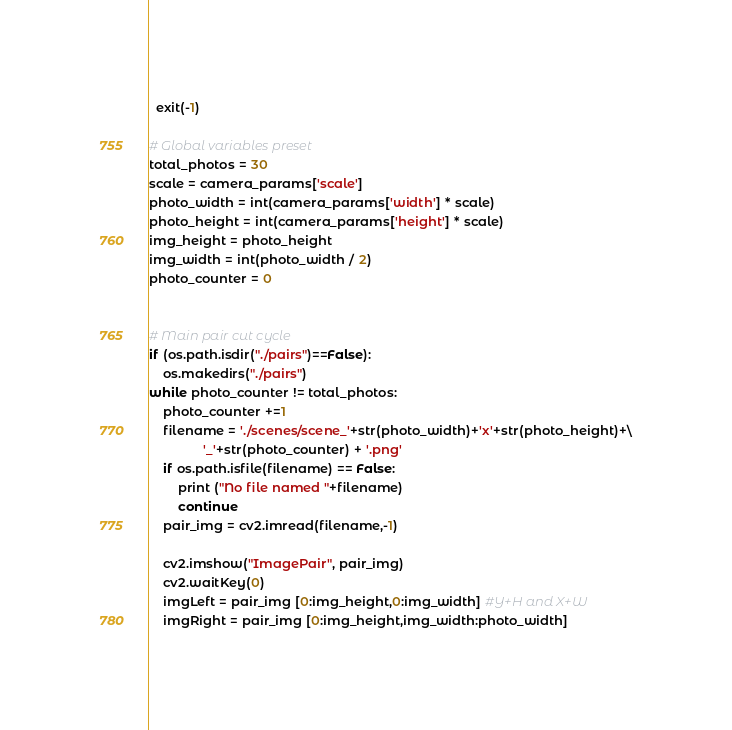<code> <loc_0><loc_0><loc_500><loc_500><_Python_>  exit(-1)

# Global variables preset
total_photos = 30
scale = camera_params['scale']
photo_width = int(camera_params['width'] * scale)
photo_height = int(camera_params['height'] * scale)
img_height = photo_height
img_width = int(photo_width / 2)
photo_counter = 0


# Main pair cut cycle
if (os.path.isdir("./pairs")==False):
    os.makedirs("./pairs")
while photo_counter != total_photos:
    photo_counter +=1
    filename = './scenes/scene_'+str(photo_width)+'x'+str(photo_height)+\
               '_'+str(photo_counter) + '.png'
    if os.path.isfile(filename) == False:
        print ("No file named "+filename)
        continue
    pair_img = cv2.imread(filename,-1)
    
    cv2.imshow("ImagePair", pair_img)
    cv2.waitKey(0)
    imgLeft = pair_img [0:img_height,0:img_width] #Y+H and X+W
    imgRight = pair_img [0:img_height,img_width:photo_width]</code> 